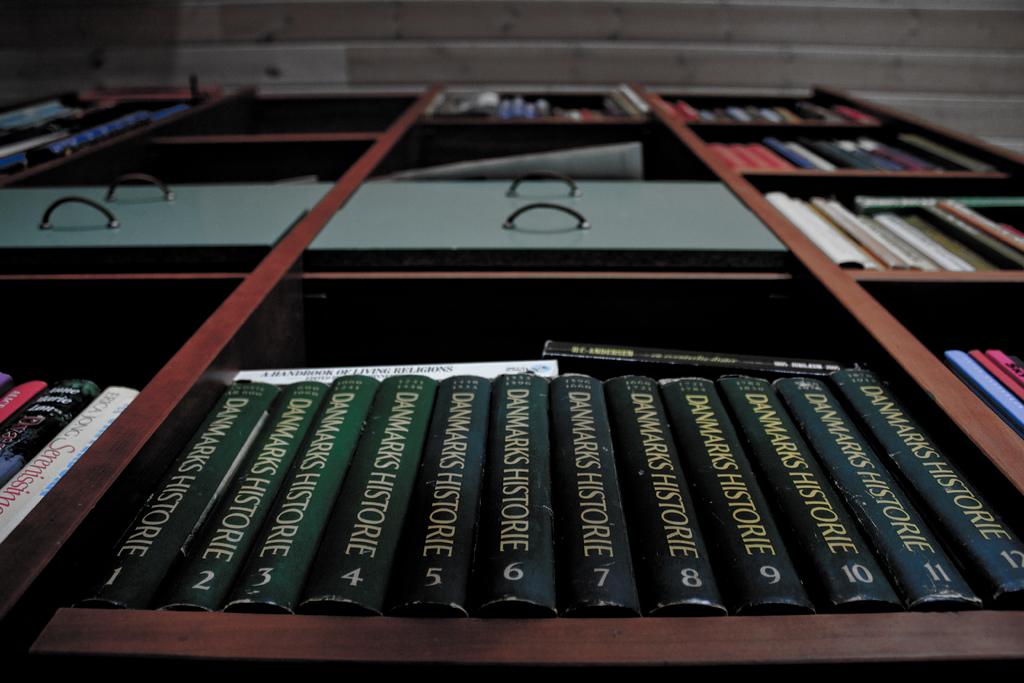How many volumes of the green book are on the shelf?
Offer a very short reply. 12. What is the book called?
Give a very brief answer. Danmarks historie. 